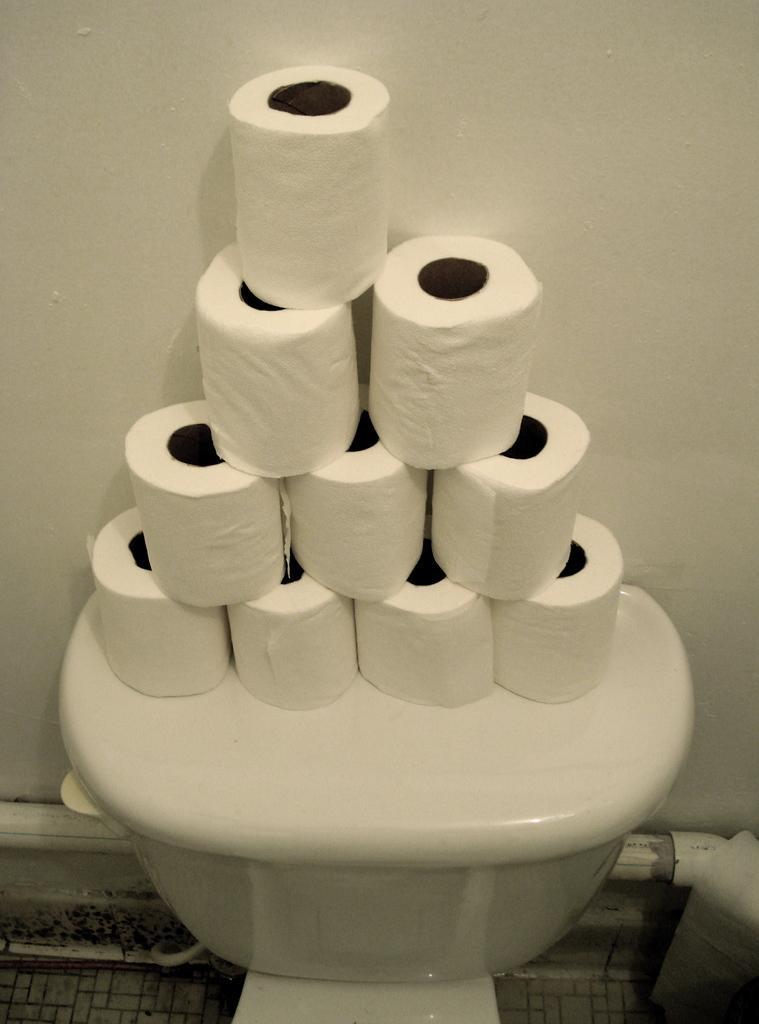How would you summarize this image in a sentence or two? In this picture I can see few toilet paper rolls on the flush tank and I can see a wall in the background. 